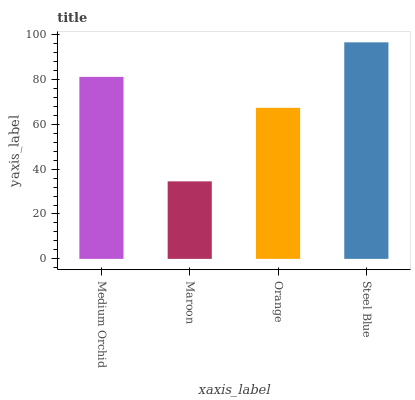Is Maroon the minimum?
Answer yes or no. Yes. Is Steel Blue the maximum?
Answer yes or no. Yes. Is Orange the minimum?
Answer yes or no. No. Is Orange the maximum?
Answer yes or no. No. Is Orange greater than Maroon?
Answer yes or no. Yes. Is Maroon less than Orange?
Answer yes or no. Yes. Is Maroon greater than Orange?
Answer yes or no. No. Is Orange less than Maroon?
Answer yes or no. No. Is Medium Orchid the high median?
Answer yes or no. Yes. Is Orange the low median?
Answer yes or no. Yes. Is Orange the high median?
Answer yes or no. No. Is Medium Orchid the low median?
Answer yes or no. No. 